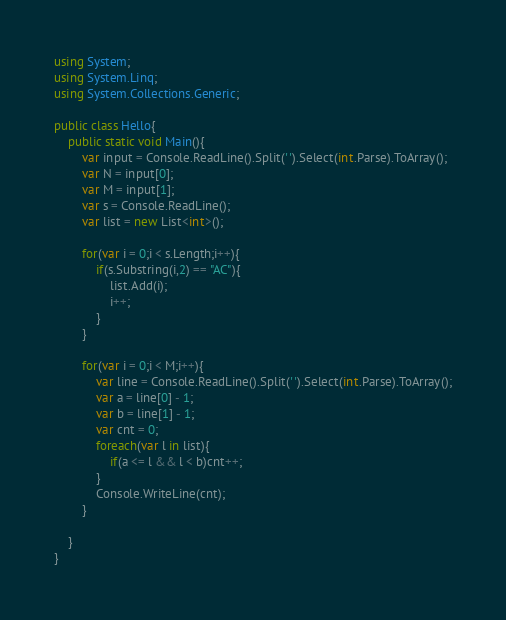Convert code to text. <code><loc_0><loc_0><loc_500><loc_500><_C#_>using System;
using System.Linq;
using System.Collections.Generic;

public class Hello{
    public static void Main(){
        var input = Console.ReadLine().Split(' ').Select(int.Parse).ToArray();
        var N = input[0];
        var M = input[1];
        var s = Console.ReadLine();
        var list = new List<int>();
        
        for(var i = 0;i < s.Length;i++){
            if(s.Substring(i,2) == "AC"){
                list.Add(i);
                i++;
            }
        }
        
        for(var i = 0;i < M;i++){
            var line = Console.ReadLine().Split(' ').Select(int.Parse).ToArray();
            var a = line[0] - 1;
            var b = line[1] - 1;
            var cnt = 0;
            foreach(var l in list){
                if(a <= l && l < b)cnt++;
            }
            Console.WriteLine(cnt);
        }
        
    }
}
</code> 